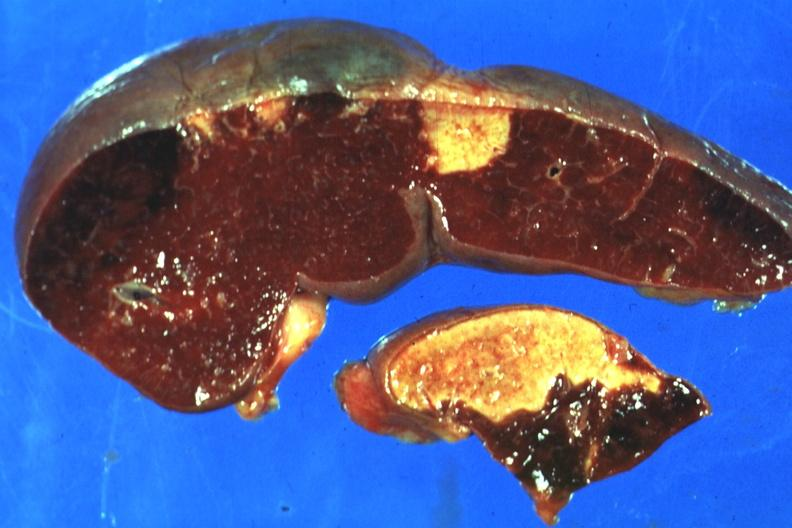s spleen present?
Answer the question using a single word or phrase. Yes 